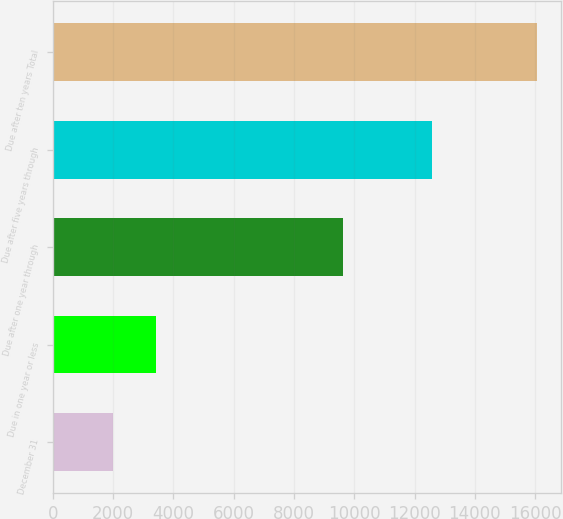<chart> <loc_0><loc_0><loc_500><loc_500><bar_chart><fcel>December 31<fcel>Due in one year or less<fcel>Due after one year through<fcel>Due after five years through<fcel>Due after ten years Total<nl><fcel>2014<fcel>3417.5<fcel>9621<fcel>12584<fcel>16049<nl></chart> 